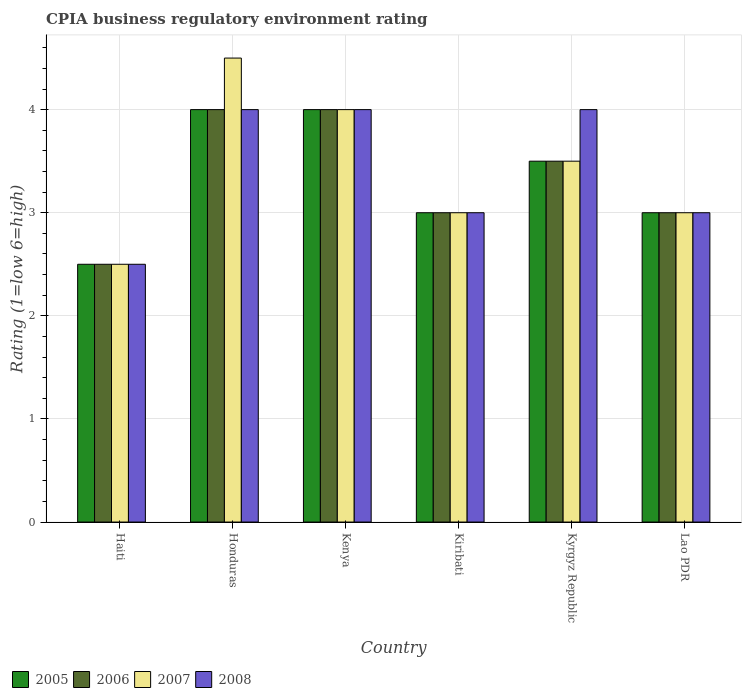How many different coloured bars are there?
Offer a very short reply. 4. Are the number of bars on each tick of the X-axis equal?
Your answer should be compact. Yes. How many bars are there on the 6th tick from the left?
Ensure brevity in your answer.  4. How many bars are there on the 1st tick from the right?
Your answer should be very brief. 4. What is the label of the 2nd group of bars from the left?
Provide a short and direct response. Honduras. In how many cases, is the number of bars for a given country not equal to the number of legend labels?
Your response must be concise. 0. Across all countries, what is the maximum CPIA rating in 2007?
Ensure brevity in your answer.  4.5. Across all countries, what is the minimum CPIA rating in 2005?
Offer a very short reply. 2.5. In which country was the CPIA rating in 2008 maximum?
Ensure brevity in your answer.  Honduras. In which country was the CPIA rating in 2005 minimum?
Offer a terse response. Haiti. What is the total CPIA rating in 2005 in the graph?
Your answer should be compact. 20. What is the difference between the CPIA rating in 2005 in Haiti and that in Honduras?
Your answer should be very brief. -1.5. What is the average CPIA rating in 2007 per country?
Make the answer very short. 3.42. What is the difference between the CPIA rating of/in 2007 and CPIA rating of/in 2008 in Honduras?
Keep it short and to the point. 0.5. What is the ratio of the CPIA rating in 2007 in Haiti to that in Kyrgyz Republic?
Offer a terse response. 0.71. What is the difference between the highest and the second highest CPIA rating in 2007?
Ensure brevity in your answer.  -1. Is the sum of the CPIA rating in 2008 in Haiti and Kyrgyz Republic greater than the maximum CPIA rating in 2006 across all countries?
Give a very brief answer. Yes. What does the 4th bar from the left in Honduras represents?
Your response must be concise. 2008. What does the 2nd bar from the right in Lao PDR represents?
Make the answer very short. 2007. How many countries are there in the graph?
Ensure brevity in your answer.  6. What is the difference between two consecutive major ticks on the Y-axis?
Keep it short and to the point. 1. Where does the legend appear in the graph?
Give a very brief answer. Bottom left. How many legend labels are there?
Your answer should be very brief. 4. How are the legend labels stacked?
Your answer should be very brief. Horizontal. What is the title of the graph?
Keep it short and to the point. CPIA business regulatory environment rating. What is the label or title of the Y-axis?
Give a very brief answer. Rating (1=low 6=high). What is the Rating (1=low 6=high) in 2006 in Honduras?
Give a very brief answer. 4. What is the Rating (1=low 6=high) of 2007 in Honduras?
Provide a succinct answer. 4.5. What is the Rating (1=low 6=high) of 2008 in Honduras?
Keep it short and to the point. 4. What is the Rating (1=low 6=high) of 2005 in Kenya?
Offer a very short reply. 4. What is the Rating (1=low 6=high) in 2007 in Kenya?
Make the answer very short. 4. What is the Rating (1=low 6=high) in 2005 in Kiribati?
Ensure brevity in your answer.  3. What is the Rating (1=low 6=high) of 2007 in Kiribati?
Your response must be concise. 3. What is the Rating (1=low 6=high) in 2005 in Kyrgyz Republic?
Provide a short and direct response. 3.5. What is the Rating (1=low 6=high) of 2008 in Kyrgyz Republic?
Ensure brevity in your answer.  4. What is the Rating (1=low 6=high) in 2005 in Lao PDR?
Your answer should be compact. 3. What is the Rating (1=low 6=high) of 2007 in Lao PDR?
Keep it short and to the point. 3. Across all countries, what is the maximum Rating (1=low 6=high) in 2005?
Keep it short and to the point. 4. Across all countries, what is the maximum Rating (1=low 6=high) in 2008?
Make the answer very short. 4. Across all countries, what is the minimum Rating (1=low 6=high) in 2006?
Provide a short and direct response. 2.5. Across all countries, what is the minimum Rating (1=low 6=high) of 2008?
Provide a succinct answer. 2.5. What is the total Rating (1=low 6=high) of 2005 in the graph?
Give a very brief answer. 20. What is the difference between the Rating (1=low 6=high) of 2005 in Haiti and that in Honduras?
Offer a terse response. -1.5. What is the difference between the Rating (1=low 6=high) in 2007 in Haiti and that in Honduras?
Offer a terse response. -2. What is the difference between the Rating (1=low 6=high) in 2005 in Haiti and that in Kenya?
Your answer should be very brief. -1.5. What is the difference between the Rating (1=low 6=high) of 2007 in Haiti and that in Kenya?
Your answer should be very brief. -1.5. What is the difference between the Rating (1=low 6=high) in 2005 in Haiti and that in Kiribati?
Provide a short and direct response. -0.5. What is the difference between the Rating (1=low 6=high) of 2006 in Haiti and that in Kyrgyz Republic?
Give a very brief answer. -1. What is the difference between the Rating (1=low 6=high) of 2007 in Haiti and that in Kyrgyz Republic?
Offer a terse response. -1. What is the difference between the Rating (1=low 6=high) of 2006 in Haiti and that in Lao PDR?
Make the answer very short. -0.5. What is the difference between the Rating (1=low 6=high) in 2005 in Honduras and that in Kenya?
Offer a terse response. 0. What is the difference between the Rating (1=low 6=high) of 2006 in Honduras and that in Kenya?
Offer a very short reply. 0. What is the difference between the Rating (1=low 6=high) of 2008 in Honduras and that in Kenya?
Your answer should be very brief. 0. What is the difference between the Rating (1=low 6=high) of 2005 in Honduras and that in Kiribati?
Provide a succinct answer. 1. What is the difference between the Rating (1=low 6=high) in 2007 in Honduras and that in Kyrgyz Republic?
Offer a terse response. 1. What is the difference between the Rating (1=low 6=high) in 2006 in Honduras and that in Lao PDR?
Your answer should be compact. 1. What is the difference between the Rating (1=low 6=high) of 2007 in Honduras and that in Lao PDR?
Offer a very short reply. 1.5. What is the difference between the Rating (1=low 6=high) in 2005 in Kenya and that in Kiribati?
Offer a very short reply. 1. What is the difference between the Rating (1=low 6=high) in 2006 in Kenya and that in Kiribati?
Your answer should be compact. 1. What is the difference between the Rating (1=low 6=high) of 2005 in Kenya and that in Kyrgyz Republic?
Provide a succinct answer. 0.5. What is the difference between the Rating (1=low 6=high) of 2006 in Kenya and that in Kyrgyz Republic?
Make the answer very short. 0.5. What is the difference between the Rating (1=low 6=high) of 2006 in Kenya and that in Lao PDR?
Give a very brief answer. 1. What is the difference between the Rating (1=low 6=high) of 2008 in Kiribati and that in Kyrgyz Republic?
Your answer should be very brief. -1. What is the difference between the Rating (1=low 6=high) of 2007 in Kyrgyz Republic and that in Lao PDR?
Make the answer very short. 0.5. What is the difference between the Rating (1=low 6=high) of 2008 in Kyrgyz Republic and that in Lao PDR?
Your answer should be very brief. 1. What is the difference between the Rating (1=low 6=high) of 2005 in Haiti and the Rating (1=low 6=high) of 2006 in Honduras?
Your response must be concise. -1.5. What is the difference between the Rating (1=low 6=high) of 2005 in Haiti and the Rating (1=low 6=high) of 2007 in Honduras?
Ensure brevity in your answer.  -2. What is the difference between the Rating (1=low 6=high) in 2006 in Haiti and the Rating (1=low 6=high) in 2008 in Honduras?
Offer a terse response. -1.5. What is the difference between the Rating (1=low 6=high) in 2007 in Haiti and the Rating (1=low 6=high) in 2008 in Honduras?
Your response must be concise. -1.5. What is the difference between the Rating (1=low 6=high) of 2005 in Haiti and the Rating (1=low 6=high) of 2007 in Kenya?
Ensure brevity in your answer.  -1.5. What is the difference between the Rating (1=low 6=high) of 2005 in Haiti and the Rating (1=low 6=high) of 2008 in Kenya?
Your answer should be compact. -1.5. What is the difference between the Rating (1=low 6=high) of 2006 in Haiti and the Rating (1=low 6=high) of 2007 in Kenya?
Offer a terse response. -1.5. What is the difference between the Rating (1=low 6=high) in 2006 in Haiti and the Rating (1=low 6=high) in 2008 in Kenya?
Make the answer very short. -1.5. What is the difference between the Rating (1=low 6=high) of 2005 in Haiti and the Rating (1=low 6=high) of 2007 in Kiribati?
Provide a succinct answer. -0.5. What is the difference between the Rating (1=low 6=high) of 2006 in Haiti and the Rating (1=low 6=high) of 2008 in Kiribati?
Give a very brief answer. -0.5. What is the difference between the Rating (1=low 6=high) in 2005 in Haiti and the Rating (1=low 6=high) in 2006 in Kyrgyz Republic?
Give a very brief answer. -1. What is the difference between the Rating (1=low 6=high) in 2006 in Haiti and the Rating (1=low 6=high) in 2007 in Kyrgyz Republic?
Keep it short and to the point. -1. What is the difference between the Rating (1=low 6=high) of 2006 in Haiti and the Rating (1=low 6=high) of 2008 in Kyrgyz Republic?
Make the answer very short. -1.5. What is the difference between the Rating (1=low 6=high) in 2006 in Haiti and the Rating (1=low 6=high) in 2008 in Lao PDR?
Provide a succinct answer. -0.5. What is the difference between the Rating (1=low 6=high) of 2007 in Haiti and the Rating (1=low 6=high) of 2008 in Lao PDR?
Keep it short and to the point. -0.5. What is the difference between the Rating (1=low 6=high) in 2005 in Honduras and the Rating (1=low 6=high) in 2008 in Kenya?
Your answer should be compact. 0. What is the difference between the Rating (1=low 6=high) in 2006 in Honduras and the Rating (1=low 6=high) in 2007 in Kenya?
Your answer should be very brief. 0. What is the difference between the Rating (1=low 6=high) of 2005 in Honduras and the Rating (1=low 6=high) of 2007 in Kiribati?
Ensure brevity in your answer.  1. What is the difference between the Rating (1=low 6=high) of 2005 in Honduras and the Rating (1=low 6=high) of 2008 in Kiribati?
Give a very brief answer. 1. What is the difference between the Rating (1=low 6=high) of 2006 in Honduras and the Rating (1=low 6=high) of 2007 in Kiribati?
Provide a short and direct response. 1. What is the difference between the Rating (1=low 6=high) of 2007 in Honduras and the Rating (1=low 6=high) of 2008 in Kiribati?
Keep it short and to the point. 1.5. What is the difference between the Rating (1=low 6=high) of 2005 in Honduras and the Rating (1=low 6=high) of 2007 in Kyrgyz Republic?
Your answer should be compact. 0.5. What is the difference between the Rating (1=low 6=high) in 2005 in Honduras and the Rating (1=low 6=high) in 2008 in Kyrgyz Republic?
Give a very brief answer. 0. What is the difference between the Rating (1=low 6=high) of 2005 in Honduras and the Rating (1=low 6=high) of 2007 in Lao PDR?
Your answer should be very brief. 1. What is the difference between the Rating (1=low 6=high) in 2005 in Honduras and the Rating (1=low 6=high) in 2008 in Lao PDR?
Your answer should be compact. 1. What is the difference between the Rating (1=low 6=high) of 2006 in Honduras and the Rating (1=low 6=high) of 2007 in Lao PDR?
Keep it short and to the point. 1. What is the difference between the Rating (1=low 6=high) in 2005 in Kenya and the Rating (1=low 6=high) in 2007 in Kiribati?
Your answer should be very brief. 1. What is the difference between the Rating (1=low 6=high) in 2006 in Kenya and the Rating (1=low 6=high) in 2007 in Kiribati?
Provide a short and direct response. 1. What is the difference between the Rating (1=low 6=high) in 2005 in Kenya and the Rating (1=low 6=high) in 2006 in Kyrgyz Republic?
Your response must be concise. 0.5. What is the difference between the Rating (1=low 6=high) of 2005 in Kenya and the Rating (1=low 6=high) of 2007 in Kyrgyz Republic?
Provide a short and direct response. 0.5. What is the difference between the Rating (1=low 6=high) in 2005 in Kenya and the Rating (1=low 6=high) in 2008 in Kyrgyz Republic?
Keep it short and to the point. 0. What is the difference between the Rating (1=low 6=high) of 2006 in Kenya and the Rating (1=low 6=high) of 2008 in Kyrgyz Republic?
Your answer should be very brief. 0. What is the difference between the Rating (1=low 6=high) in 2005 in Kenya and the Rating (1=low 6=high) in 2006 in Lao PDR?
Provide a short and direct response. 1. What is the difference between the Rating (1=low 6=high) in 2006 in Kenya and the Rating (1=low 6=high) in 2007 in Lao PDR?
Offer a very short reply. 1. What is the difference between the Rating (1=low 6=high) of 2006 in Kenya and the Rating (1=low 6=high) of 2008 in Lao PDR?
Your answer should be compact. 1. What is the difference between the Rating (1=low 6=high) in 2005 in Kiribati and the Rating (1=low 6=high) in 2006 in Kyrgyz Republic?
Provide a short and direct response. -0.5. What is the difference between the Rating (1=low 6=high) of 2006 in Kiribati and the Rating (1=low 6=high) of 2007 in Kyrgyz Republic?
Keep it short and to the point. -0.5. What is the difference between the Rating (1=low 6=high) in 2006 in Kiribati and the Rating (1=low 6=high) in 2008 in Kyrgyz Republic?
Provide a short and direct response. -1. What is the difference between the Rating (1=low 6=high) in 2005 in Kiribati and the Rating (1=low 6=high) in 2006 in Lao PDR?
Make the answer very short. 0. What is the difference between the Rating (1=low 6=high) of 2005 in Kiribati and the Rating (1=low 6=high) of 2007 in Lao PDR?
Offer a very short reply. 0. What is the difference between the Rating (1=low 6=high) of 2005 in Kiribati and the Rating (1=low 6=high) of 2008 in Lao PDR?
Make the answer very short. 0. What is the difference between the Rating (1=low 6=high) of 2006 in Kiribati and the Rating (1=low 6=high) of 2007 in Lao PDR?
Your response must be concise. 0. What is the difference between the Rating (1=low 6=high) in 2006 in Kiribati and the Rating (1=low 6=high) in 2008 in Lao PDR?
Provide a short and direct response. 0. What is the difference between the Rating (1=low 6=high) of 2007 in Kiribati and the Rating (1=low 6=high) of 2008 in Lao PDR?
Give a very brief answer. 0. What is the difference between the Rating (1=low 6=high) in 2005 in Kyrgyz Republic and the Rating (1=low 6=high) in 2006 in Lao PDR?
Your answer should be compact. 0.5. What is the difference between the Rating (1=low 6=high) in 2006 in Kyrgyz Republic and the Rating (1=low 6=high) in 2008 in Lao PDR?
Provide a short and direct response. 0.5. What is the difference between the Rating (1=low 6=high) of 2007 in Kyrgyz Republic and the Rating (1=low 6=high) of 2008 in Lao PDR?
Provide a short and direct response. 0.5. What is the average Rating (1=low 6=high) in 2005 per country?
Give a very brief answer. 3.33. What is the average Rating (1=low 6=high) in 2007 per country?
Keep it short and to the point. 3.42. What is the average Rating (1=low 6=high) in 2008 per country?
Ensure brevity in your answer.  3.42. What is the difference between the Rating (1=low 6=high) of 2005 and Rating (1=low 6=high) of 2007 in Haiti?
Your response must be concise. 0. What is the difference between the Rating (1=low 6=high) of 2005 and Rating (1=low 6=high) of 2008 in Haiti?
Make the answer very short. 0. What is the difference between the Rating (1=low 6=high) in 2006 and Rating (1=low 6=high) in 2008 in Haiti?
Your answer should be very brief. 0. What is the difference between the Rating (1=low 6=high) of 2007 and Rating (1=low 6=high) of 2008 in Haiti?
Give a very brief answer. 0. What is the difference between the Rating (1=low 6=high) of 2005 and Rating (1=low 6=high) of 2008 in Honduras?
Offer a terse response. 0. What is the difference between the Rating (1=low 6=high) of 2007 and Rating (1=low 6=high) of 2008 in Honduras?
Your response must be concise. 0.5. What is the difference between the Rating (1=low 6=high) in 2005 and Rating (1=low 6=high) in 2007 in Kenya?
Provide a succinct answer. 0. What is the difference between the Rating (1=low 6=high) in 2006 and Rating (1=low 6=high) in 2008 in Kenya?
Provide a short and direct response. 0. What is the difference between the Rating (1=low 6=high) in 2006 and Rating (1=low 6=high) in 2007 in Kiribati?
Make the answer very short. 0. What is the difference between the Rating (1=low 6=high) of 2005 and Rating (1=low 6=high) of 2008 in Kyrgyz Republic?
Provide a succinct answer. -0.5. What is the difference between the Rating (1=low 6=high) in 2006 and Rating (1=low 6=high) in 2008 in Kyrgyz Republic?
Your response must be concise. -0.5. What is the difference between the Rating (1=low 6=high) in 2007 and Rating (1=low 6=high) in 2008 in Kyrgyz Republic?
Provide a short and direct response. -0.5. What is the difference between the Rating (1=low 6=high) in 2005 and Rating (1=low 6=high) in 2006 in Lao PDR?
Your answer should be very brief. 0. What is the difference between the Rating (1=low 6=high) of 2005 and Rating (1=low 6=high) of 2007 in Lao PDR?
Offer a terse response. 0. What is the difference between the Rating (1=low 6=high) in 2005 and Rating (1=low 6=high) in 2008 in Lao PDR?
Offer a terse response. 0. What is the difference between the Rating (1=low 6=high) of 2006 and Rating (1=low 6=high) of 2008 in Lao PDR?
Give a very brief answer. 0. What is the ratio of the Rating (1=low 6=high) in 2006 in Haiti to that in Honduras?
Your response must be concise. 0.62. What is the ratio of the Rating (1=low 6=high) of 2007 in Haiti to that in Honduras?
Make the answer very short. 0.56. What is the ratio of the Rating (1=low 6=high) of 2006 in Haiti to that in Kenya?
Offer a very short reply. 0.62. What is the ratio of the Rating (1=low 6=high) of 2007 in Haiti to that in Kenya?
Keep it short and to the point. 0.62. What is the ratio of the Rating (1=low 6=high) in 2008 in Haiti to that in Kenya?
Your answer should be very brief. 0.62. What is the ratio of the Rating (1=low 6=high) in 2005 in Haiti to that in Kiribati?
Give a very brief answer. 0.83. What is the ratio of the Rating (1=low 6=high) in 2006 in Haiti to that in Kiribati?
Your answer should be compact. 0.83. What is the ratio of the Rating (1=low 6=high) in 2005 in Haiti to that in Kyrgyz Republic?
Provide a succinct answer. 0.71. What is the ratio of the Rating (1=low 6=high) in 2006 in Haiti to that in Kyrgyz Republic?
Ensure brevity in your answer.  0.71. What is the ratio of the Rating (1=low 6=high) in 2008 in Haiti to that in Kyrgyz Republic?
Ensure brevity in your answer.  0.62. What is the ratio of the Rating (1=low 6=high) of 2006 in Haiti to that in Lao PDR?
Give a very brief answer. 0.83. What is the ratio of the Rating (1=low 6=high) in 2006 in Honduras to that in Kenya?
Provide a succinct answer. 1. What is the ratio of the Rating (1=low 6=high) in 2008 in Honduras to that in Kenya?
Keep it short and to the point. 1. What is the ratio of the Rating (1=low 6=high) in 2005 in Honduras to that in Kiribati?
Make the answer very short. 1.33. What is the ratio of the Rating (1=low 6=high) of 2006 in Honduras to that in Kiribati?
Your answer should be compact. 1.33. What is the ratio of the Rating (1=low 6=high) of 2008 in Honduras to that in Kyrgyz Republic?
Offer a very short reply. 1. What is the ratio of the Rating (1=low 6=high) in 2005 in Honduras to that in Lao PDR?
Ensure brevity in your answer.  1.33. What is the ratio of the Rating (1=low 6=high) in 2008 in Honduras to that in Lao PDR?
Provide a short and direct response. 1.33. What is the ratio of the Rating (1=low 6=high) of 2007 in Kenya to that in Kiribati?
Provide a succinct answer. 1.33. What is the ratio of the Rating (1=low 6=high) of 2005 in Kenya to that in Kyrgyz Republic?
Your response must be concise. 1.14. What is the ratio of the Rating (1=low 6=high) of 2007 in Kenya to that in Kyrgyz Republic?
Your answer should be compact. 1.14. What is the ratio of the Rating (1=low 6=high) of 2006 in Kenya to that in Lao PDR?
Your answer should be compact. 1.33. What is the ratio of the Rating (1=low 6=high) of 2007 in Kenya to that in Lao PDR?
Provide a succinct answer. 1.33. What is the ratio of the Rating (1=low 6=high) of 2008 in Kenya to that in Lao PDR?
Make the answer very short. 1.33. What is the ratio of the Rating (1=low 6=high) of 2007 in Kiribati to that in Kyrgyz Republic?
Your answer should be compact. 0.86. What is the ratio of the Rating (1=low 6=high) of 2008 in Kiribati to that in Kyrgyz Republic?
Offer a terse response. 0.75. What is the ratio of the Rating (1=low 6=high) in 2005 in Kiribati to that in Lao PDR?
Give a very brief answer. 1. What is the ratio of the Rating (1=low 6=high) of 2006 in Kiribati to that in Lao PDR?
Your answer should be very brief. 1. What is the ratio of the Rating (1=low 6=high) in 2007 in Kiribati to that in Lao PDR?
Provide a succinct answer. 1. What is the ratio of the Rating (1=low 6=high) in 2008 in Kiribati to that in Lao PDR?
Give a very brief answer. 1. What is the ratio of the Rating (1=low 6=high) of 2006 in Kyrgyz Republic to that in Lao PDR?
Offer a very short reply. 1.17. What is the ratio of the Rating (1=low 6=high) of 2008 in Kyrgyz Republic to that in Lao PDR?
Your answer should be very brief. 1.33. What is the difference between the highest and the second highest Rating (1=low 6=high) in 2007?
Provide a succinct answer. 0.5. What is the difference between the highest and the second highest Rating (1=low 6=high) of 2008?
Provide a succinct answer. 0. What is the difference between the highest and the lowest Rating (1=low 6=high) of 2005?
Your answer should be compact. 1.5. What is the difference between the highest and the lowest Rating (1=low 6=high) in 2006?
Provide a succinct answer. 1.5. 